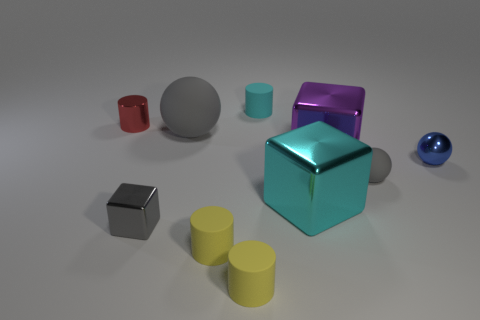What time of day does the lighting in this image suggest? The lighting in the image does not hint at a specific time of day since it appears to be a studio setting. The source of light seems artificial, likely a neutral, diffused light used in photography to evenly illuminate the scene without causing harsh shadows. So, it's likely that the environment is controlled, and not indicative of natural outdoor lighting. 